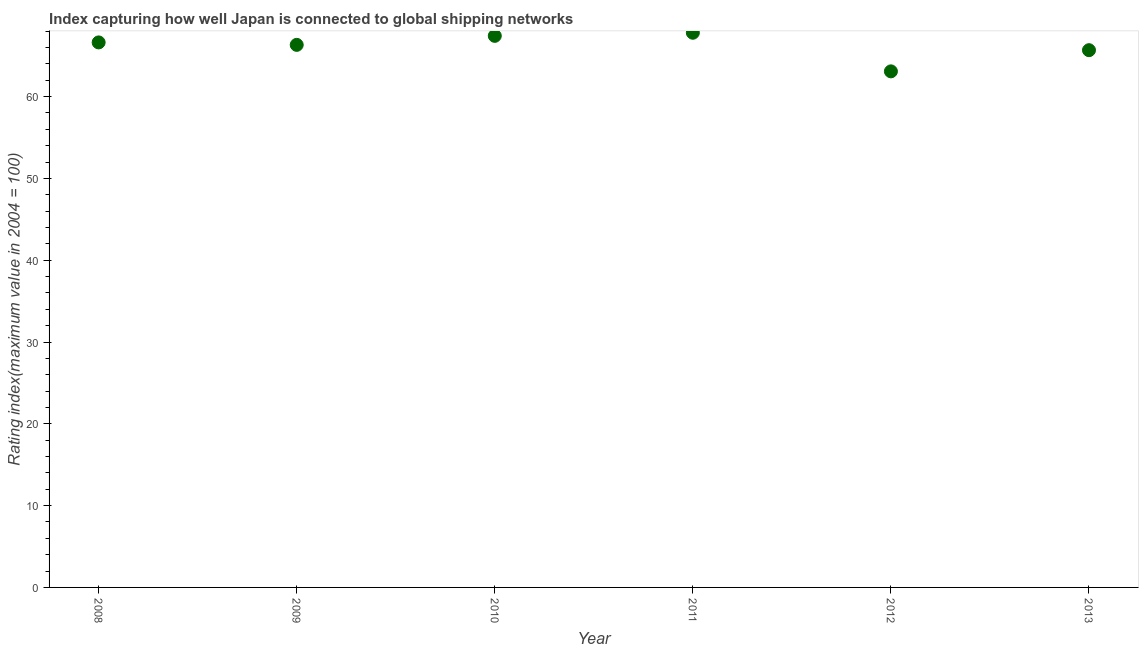What is the liner shipping connectivity index in 2011?
Offer a terse response. 67.81. Across all years, what is the maximum liner shipping connectivity index?
Provide a succinct answer. 67.81. Across all years, what is the minimum liner shipping connectivity index?
Your response must be concise. 63.09. What is the sum of the liner shipping connectivity index?
Provide a short and direct response. 396.97. What is the difference between the liner shipping connectivity index in 2010 and 2013?
Provide a short and direct response. 1.75. What is the average liner shipping connectivity index per year?
Provide a succinct answer. 66.16. What is the median liner shipping connectivity index?
Make the answer very short. 66.48. In how many years, is the liner shipping connectivity index greater than 46 ?
Make the answer very short. 6. Do a majority of the years between 2009 and 2012 (inclusive) have liner shipping connectivity index greater than 48 ?
Your answer should be compact. Yes. What is the ratio of the liner shipping connectivity index in 2008 to that in 2011?
Provide a succinct answer. 0.98. What is the difference between the highest and the second highest liner shipping connectivity index?
Your response must be concise. 0.38. What is the difference between the highest and the lowest liner shipping connectivity index?
Give a very brief answer. 4.72. In how many years, is the liner shipping connectivity index greater than the average liner shipping connectivity index taken over all years?
Your answer should be compact. 4. How many dotlines are there?
Your response must be concise. 1. Does the graph contain any zero values?
Your answer should be compact. No. What is the title of the graph?
Keep it short and to the point. Index capturing how well Japan is connected to global shipping networks. What is the label or title of the Y-axis?
Your response must be concise. Rating index(maximum value in 2004 = 100). What is the Rating index(maximum value in 2004 = 100) in 2008?
Offer a very short reply. 66.63. What is the Rating index(maximum value in 2004 = 100) in 2009?
Offer a terse response. 66.33. What is the Rating index(maximum value in 2004 = 100) in 2010?
Keep it short and to the point. 67.43. What is the Rating index(maximum value in 2004 = 100) in 2011?
Your answer should be very brief. 67.81. What is the Rating index(maximum value in 2004 = 100) in 2012?
Provide a succinct answer. 63.09. What is the Rating index(maximum value in 2004 = 100) in 2013?
Your answer should be very brief. 65.68. What is the difference between the Rating index(maximum value in 2004 = 100) in 2008 and 2011?
Keep it short and to the point. -1.18. What is the difference between the Rating index(maximum value in 2004 = 100) in 2008 and 2012?
Make the answer very short. 3.54. What is the difference between the Rating index(maximum value in 2004 = 100) in 2008 and 2013?
Provide a succinct answer. 0.95. What is the difference between the Rating index(maximum value in 2004 = 100) in 2009 and 2010?
Make the answer very short. -1.1. What is the difference between the Rating index(maximum value in 2004 = 100) in 2009 and 2011?
Provide a short and direct response. -1.48. What is the difference between the Rating index(maximum value in 2004 = 100) in 2009 and 2012?
Your answer should be very brief. 3.24. What is the difference between the Rating index(maximum value in 2004 = 100) in 2009 and 2013?
Keep it short and to the point. 0.65. What is the difference between the Rating index(maximum value in 2004 = 100) in 2010 and 2011?
Ensure brevity in your answer.  -0.38. What is the difference between the Rating index(maximum value in 2004 = 100) in 2010 and 2012?
Your answer should be very brief. 4.34. What is the difference between the Rating index(maximum value in 2004 = 100) in 2010 and 2013?
Give a very brief answer. 1.75. What is the difference between the Rating index(maximum value in 2004 = 100) in 2011 and 2012?
Your answer should be compact. 4.72. What is the difference between the Rating index(maximum value in 2004 = 100) in 2011 and 2013?
Your answer should be very brief. 2.13. What is the difference between the Rating index(maximum value in 2004 = 100) in 2012 and 2013?
Offer a terse response. -2.59. What is the ratio of the Rating index(maximum value in 2004 = 100) in 2008 to that in 2010?
Your response must be concise. 0.99. What is the ratio of the Rating index(maximum value in 2004 = 100) in 2008 to that in 2012?
Offer a very short reply. 1.06. What is the ratio of the Rating index(maximum value in 2004 = 100) in 2008 to that in 2013?
Keep it short and to the point. 1.01. What is the ratio of the Rating index(maximum value in 2004 = 100) in 2009 to that in 2012?
Offer a very short reply. 1.05. What is the ratio of the Rating index(maximum value in 2004 = 100) in 2009 to that in 2013?
Offer a terse response. 1.01. What is the ratio of the Rating index(maximum value in 2004 = 100) in 2010 to that in 2012?
Make the answer very short. 1.07. What is the ratio of the Rating index(maximum value in 2004 = 100) in 2011 to that in 2012?
Offer a terse response. 1.07. What is the ratio of the Rating index(maximum value in 2004 = 100) in 2011 to that in 2013?
Your response must be concise. 1.03. What is the ratio of the Rating index(maximum value in 2004 = 100) in 2012 to that in 2013?
Your answer should be compact. 0.96. 